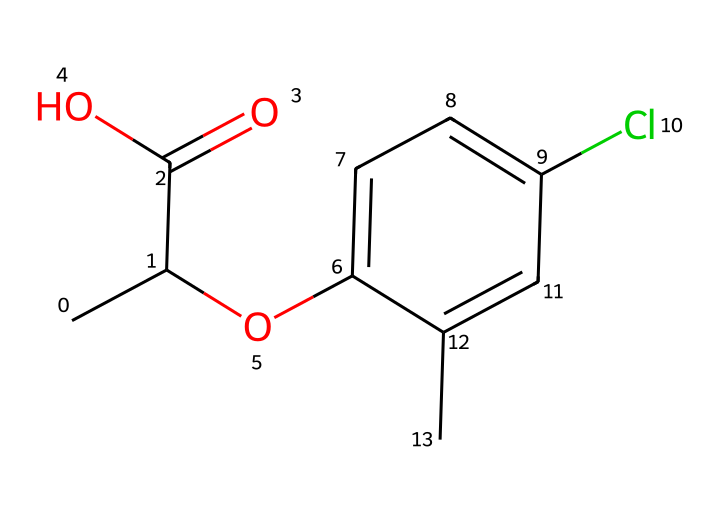What is the chemical name of this herbicide? The SMILES representation corresponds to the chemical structure of mecoprop, which is a selective herbicide.
Answer: mecoprop How many carbon atoms are in the molecular structure? By analyzing the SMILES, you count 10 carbon atoms represented in the chain and rings.
Answer: 10 How many chlorine atoms are present in the molecule? There is one chlorine atom in the structure, which is indicated by the "Cl" present in the SMILES.
Answer: 1 What type of functional group is present at the end of the carbon chain? The "C(=O)O" in the SMILES indicates that there is a carboxylic acid functional group (which consists of a carbon double bonded to an oxygen and single bonded to an OH group) at the end of the chain.
Answer: carboxylic acid What is the significance of the chlorine substitution in mecoprop? The chlorine atom in mecoprop contributes to its herbicidal activity by enhancing the molecule's ability to interact with target plant enzymes, making it effective in controlling unwanted plants.
Answer: enhance activity Does mecoprop have a phenolic structure? Yes, the presence of the aromatic ring in the SMILES ("c1ccc(...") indicates that mecoprop contains a phenolic structure, which may contribute to its biological activity.
Answer: yes 